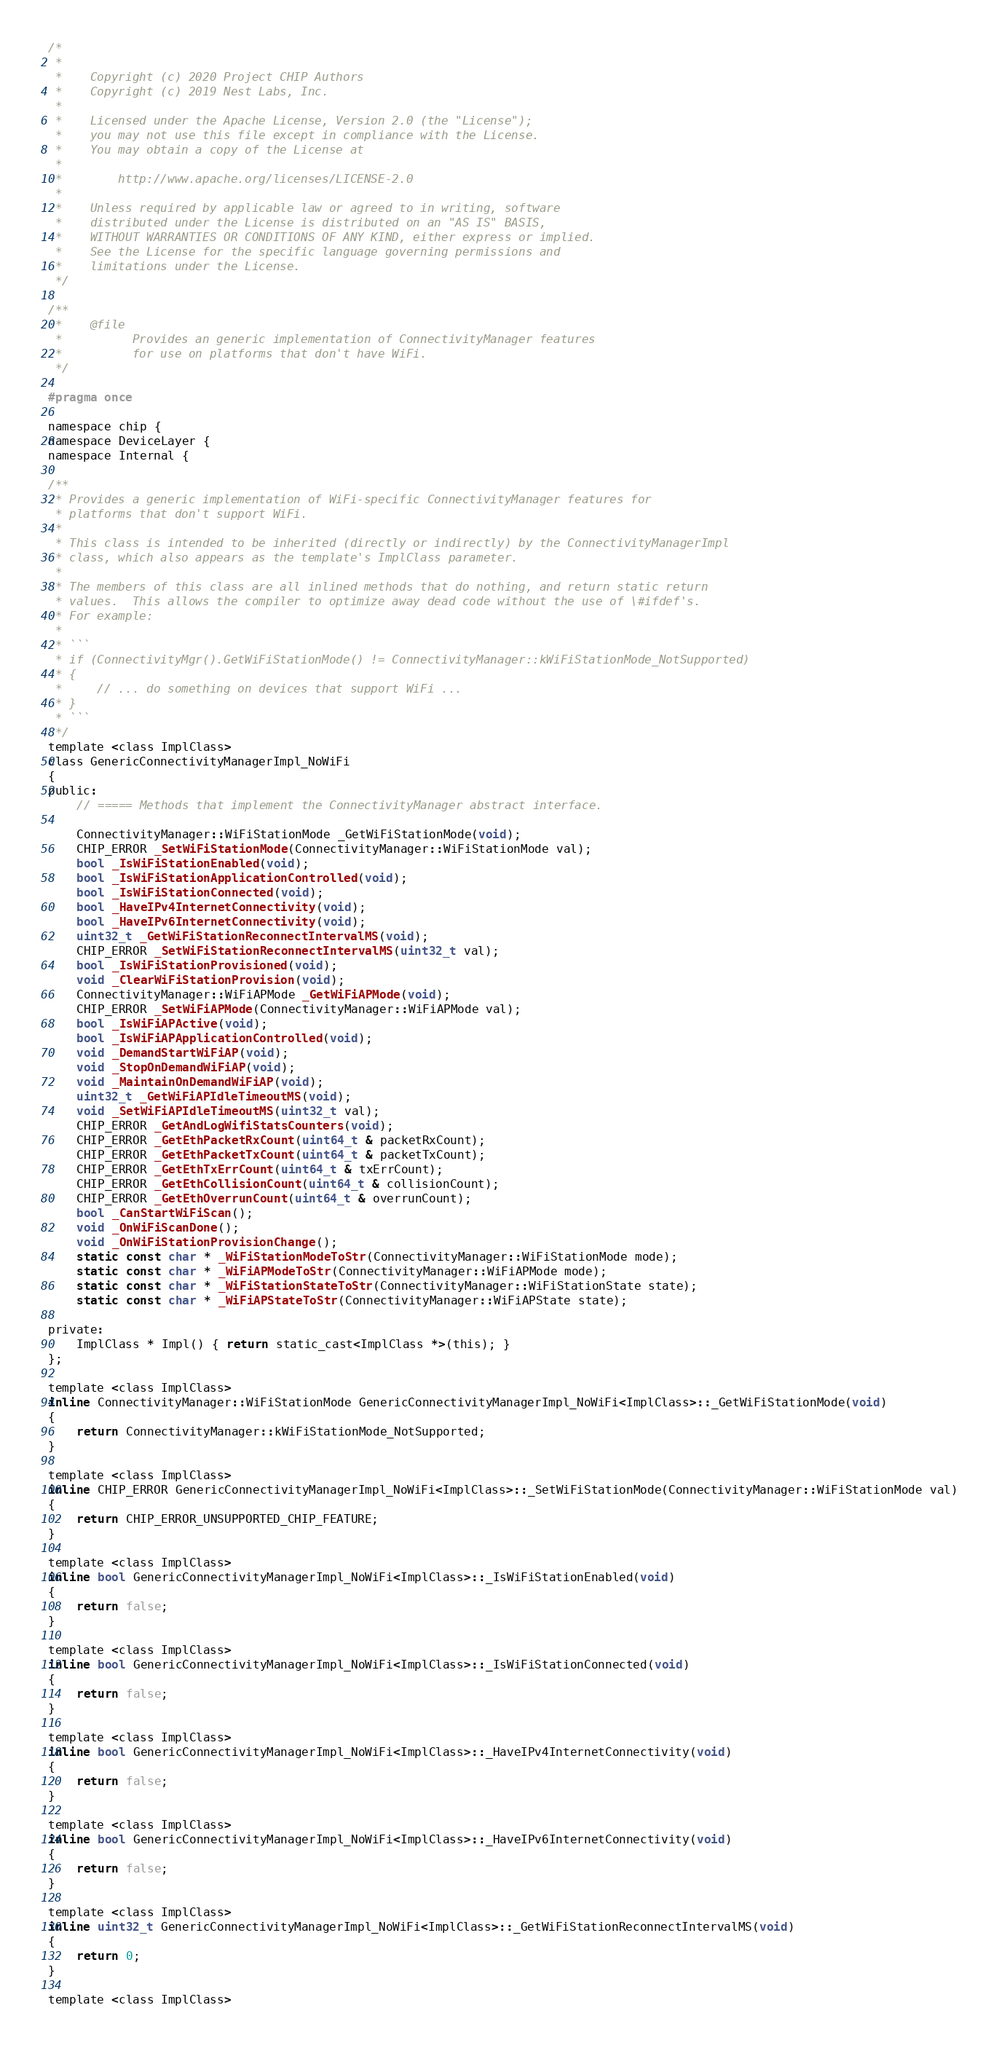<code> <loc_0><loc_0><loc_500><loc_500><_C_>/*
 *
 *    Copyright (c) 2020 Project CHIP Authors
 *    Copyright (c) 2019 Nest Labs, Inc.
 *
 *    Licensed under the Apache License, Version 2.0 (the "License");
 *    you may not use this file except in compliance with the License.
 *    You may obtain a copy of the License at
 *
 *        http://www.apache.org/licenses/LICENSE-2.0
 *
 *    Unless required by applicable law or agreed to in writing, software
 *    distributed under the License is distributed on an "AS IS" BASIS,
 *    WITHOUT WARRANTIES OR CONDITIONS OF ANY KIND, either express or implied.
 *    See the License for the specific language governing permissions and
 *    limitations under the License.
 */

/**
 *    @file
 *          Provides an generic implementation of ConnectivityManager features
 *          for use on platforms that don't have WiFi.
 */

#pragma once

namespace chip {
namespace DeviceLayer {
namespace Internal {

/**
 * Provides a generic implementation of WiFi-specific ConnectivityManager features for
 * platforms that don't support WiFi.
 *
 * This class is intended to be inherited (directly or indirectly) by the ConnectivityManagerImpl
 * class, which also appears as the template's ImplClass parameter.
 *
 * The members of this class are all inlined methods that do nothing, and return static return
 * values.  This allows the compiler to optimize away dead code without the use of \#ifdef's.
 * For example:
 *
 * ```
 * if (ConnectivityMgr().GetWiFiStationMode() != ConnectivityManager::kWiFiStationMode_NotSupported)
 * {
 *     // ... do something on devices that support WiFi ...
 * }
 * ```
 */
template <class ImplClass>
class GenericConnectivityManagerImpl_NoWiFi
{
public:
    // ===== Methods that implement the ConnectivityManager abstract interface.

    ConnectivityManager::WiFiStationMode _GetWiFiStationMode(void);
    CHIP_ERROR _SetWiFiStationMode(ConnectivityManager::WiFiStationMode val);
    bool _IsWiFiStationEnabled(void);
    bool _IsWiFiStationApplicationControlled(void);
    bool _IsWiFiStationConnected(void);
    bool _HaveIPv4InternetConnectivity(void);
    bool _HaveIPv6InternetConnectivity(void);
    uint32_t _GetWiFiStationReconnectIntervalMS(void);
    CHIP_ERROR _SetWiFiStationReconnectIntervalMS(uint32_t val);
    bool _IsWiFiStationProvisioned(void);
    void _ClearWiFiStationProvision(void);
    ConnectivityManager::WiFiAPMode _GetWiFiAPMode(void);
    CHIP_ERROR _SetWiFiAPMode(ConnectivityManager::WiFiAPMode val);
    bool _IsWiFiAPActive(void);
    bool _IsWiFiAPApplicationControlled(void);
    void _DemandStartWiFiAP(void);
    void _StopOnDemandWiFiAP(void);
    void _MaintainOnDemandWiFiAP(void);
    uint32_t _GetWiFiAPIdleTimeoutMS(void);
    void _SetWiFiAPIdleTimeoutMS(uint32_t val);
    CHIP_ERROR _GetAndLogWifiStatsCounters(void);
    CHIP_ERROR _GetEthPacketRxCount(uint64_t & packetRxCount);
    CHIP_ERROR _GetEthPacketTxCount(uint64_t & packetTxCount);
    CHIP_ERROR _GetEthTxErrCount(uint64_t & txErrCount);
    CHIP_ERROR _GetEthCollisionCount(uint64_t & collisionCount);
    CHIP_ERROR _GetEthOverrunCount(uint64_t & overrunCount);
    bool _CanStartWiFiScan();
    void _OnWiFiScanDone();
    void _OnWiFiStationProvisionChange();
    static const char * _WiFiStationModeToStr(ConnectivityManager::WiFiStationMode mode);
    static const char * _WiFiAPModeToStr(ConnectivityManager::WiFiAPMode mode);
    static const char * _WiFiStationStateToStr(ConnectivityManager::WiFiStationState state);
    static const char * _WiFiAPStateToStr(ConnectivityManager::WiFiAPState state);

private:
    ImplClass * Impl() { return static_cast<ImplClass *>(this); }
};

template <class ImplClass>
inline ConnectivityManager::WiFiStationMode GenericConnectivityManagerImpl_NoWiFi<ImplClass>::_GetWiFiStationMode(void)
{
    return ConnectivityManager::kWiFiStationMode_NotSupported;
}

template <class ImplClass>
inline CHIP_ERROR GenericConnectivityManagerImpl_NoWiFi<ImplClass>::_SetWiFiStationMode(ConnectivityManager::WiFiStationMode val)
{
    return CHIP_ERROR_UNSUPPORTED_CHIP_FEATURE;
}

template <class ImplClass>
inline bool GenericConnectivityManagerImpl_NoWiFi<ImplClass>::_IsWiFiStationEnabled(void)
{
    return false;
}

template <class ImplClass>
inline bool GenericConnectivityManagerImpl_NoWiFi<ImplClass>::_IsWiFiStationConnected(void)
{
    return false;
}

template <class ImplClass>
inline bool GenericConnectivityManagerImpl_NoWiFi<ImplClass>::_HaveIPv4InternetConnectivity(void)
{
    return false;
}

template <class ImplClass>
inline bool GenericConnectivityManagerImpl_NoWiFi<ImplClass>::_HaveIPv6InternetConnectivity(void)
{
    return false;
}

template <class ImplClass>
inline uint32_t GenericConnectivityManagerImpl_NoWiFi<ImplClass>::_GetWiFiStationReconnectIntervalMS(void)
{
    return 0;
}

template <class ImplClass></code> 